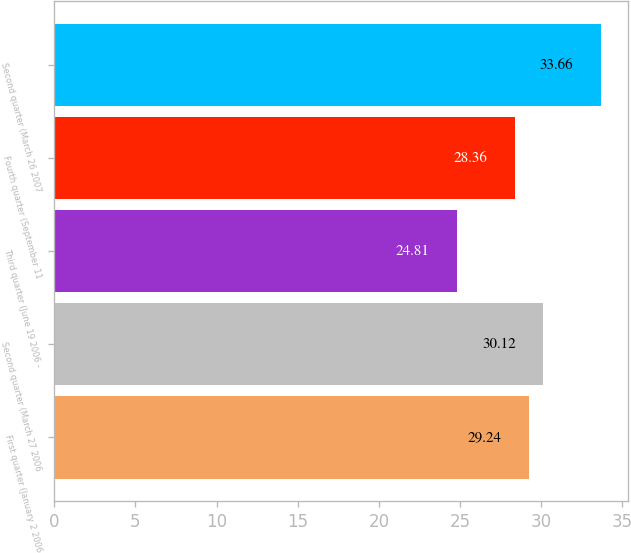<chart> <loc_0><loc_0><loc_500><loc_500><bar_chart><fcel>First quarter (January 2 2006<fcel>Second quarter (March 27 2006<fcel>Third quarter (June 19 2006 -<fcel>Fourth quarter (September 11<fcel>Second quarter (March 26 2007<nl><fcel>29.24<fcel>30.12<fcel>24.81<fcel>28.36<fcel>33.66<nl></chart> 